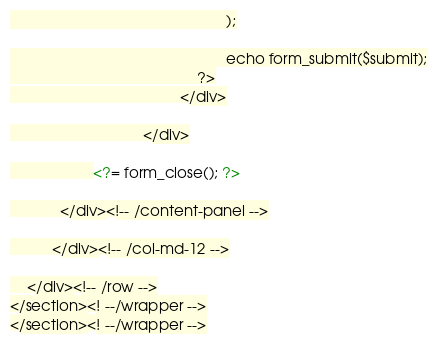<code> <loc_0><loc_0><loc_500><loc_500><_PHP_>													);

													echo form_submit($submit);
											 ?>
										 </div>

						 	    </div>

              		<?= form_close(); ?>

            </div><!-- /content-panel -->

          </div><!-- /col-md-12 -->

    </div><!-- /row -->
</section><! --/wrapper -->
</section><! --/wrapper -->
</code> 